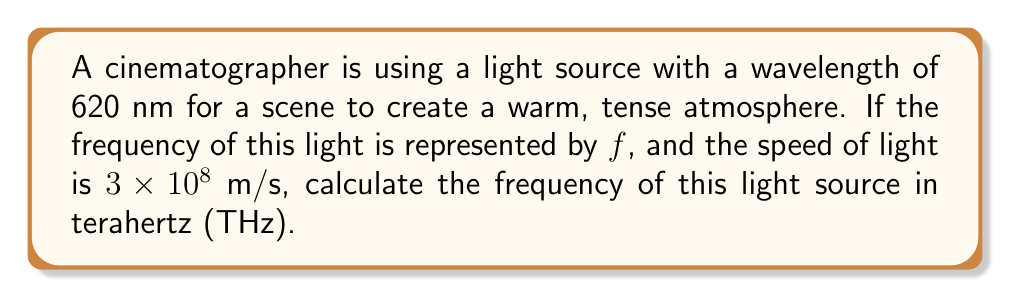Solve this math problem. To solve this problem, we'll use the wave equation that relates the speed of light, wavelength, and frequency:

$$c = \lambda f$$

Where:
$c$ is the speed of light (3 × 10^8 m/s)
$\lambda$ is the wavelength (620 nm = 620 × 10^-9 m)
$f$ is the frequency (what we need to find)

Step 1: Rearrange the equation to solve for frequency:
$$f = \frac{c}{\lambda}$$

Step 2: Substitute the known values:
$$f = \frac{3 \times 10^8 \text{ m/s}}{620 \times 10^{-9} \text{ m}}$$

Step 3: Calculate:
$$f = 4.8387 \times 10^{14} \text{ Hz}$$

Step 4: Convert Hz to THz (1 THz = 10^12 Hz):
$$f = \frac{4.8387 \times 10^{14}}{10^{12}} \text{ THz} = 483.87 \text{ THz}$$

This frequency corresponds to the orange-red part of the visible spectrum, which indeed creates a warm atmosphere as desired by the cinematographer.
Answer: 483.87 THz 